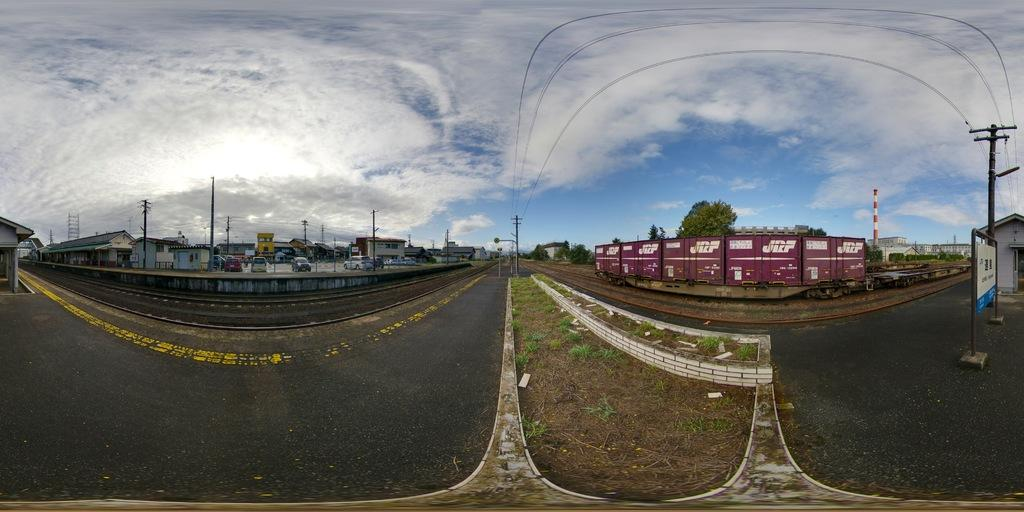What type of transportation infrastructure is present in the image? There is a railway track in the image. What vehicles are visible in the image? There are cars and a train in the image. What structures can be seen in the image? There are poles, buildings, and trees in the image. Can you describe the natural environment in the image? There is grass visible in the image, and the sky is visible as well. What is the weight of the representative in the image? There is no representative present in the image, so it is not possible to determine their weight. How does the train slip on the grass in the image? The train does not slip on the grass in the image; it is stationary on the railway track. 